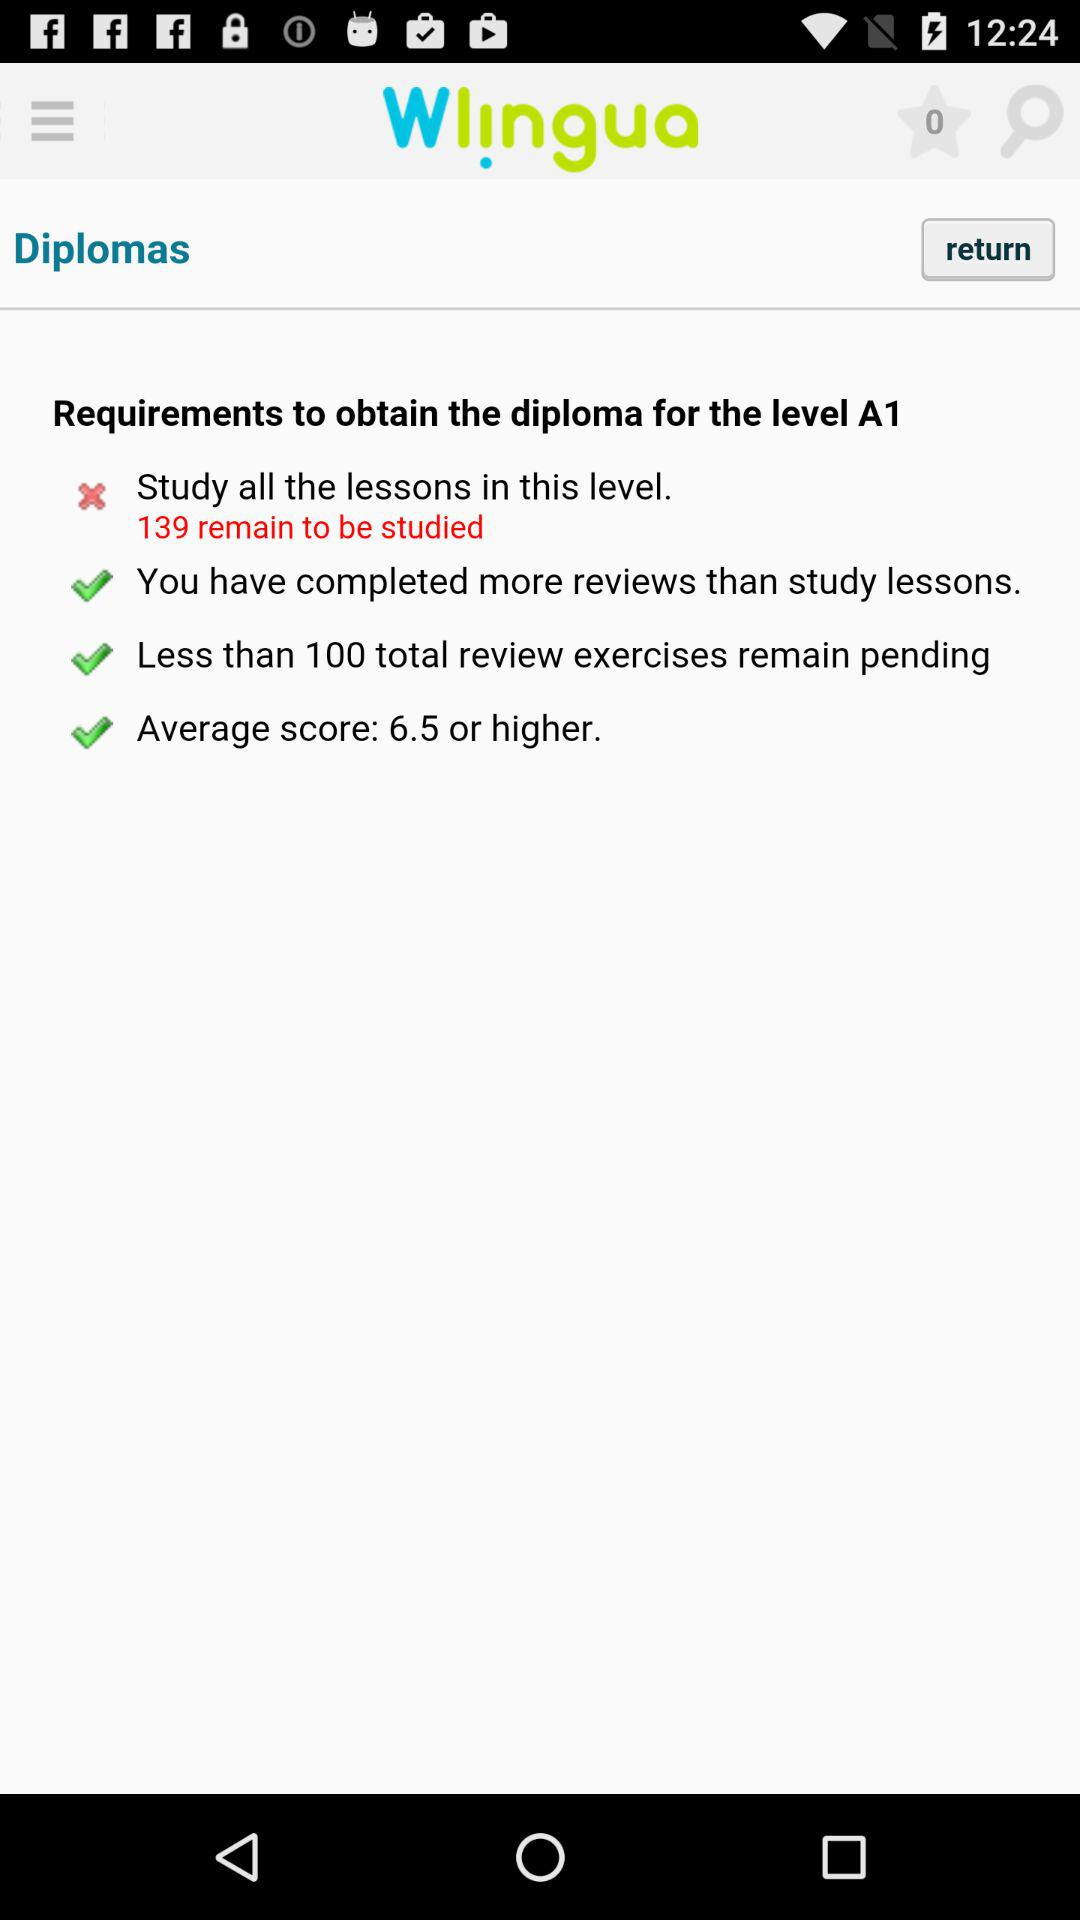How many more lessons need to be studied to obtain the diploma for the level A1?
Answer the question using a single word or phrase. 139 